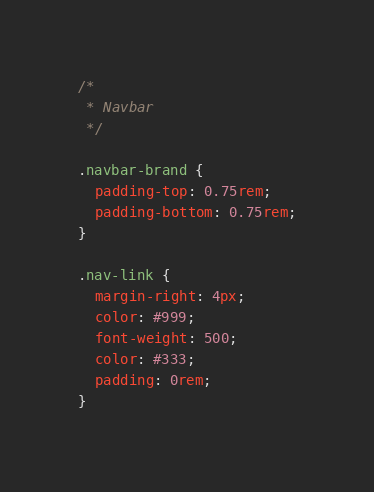<code> <loc_0><loc_0><loc_500><loc_500><_CSS_>/*
 * Navbar
 */

.navbar-brand {
  padding-top: 0.75rem;
  padding-bottom: 0.75rem;
}

.nav-link {
  margin-right: 4px;
  color: #999;
  font-weight: 500;
  color: #333;
  padding: 0rem;
}
</code> 